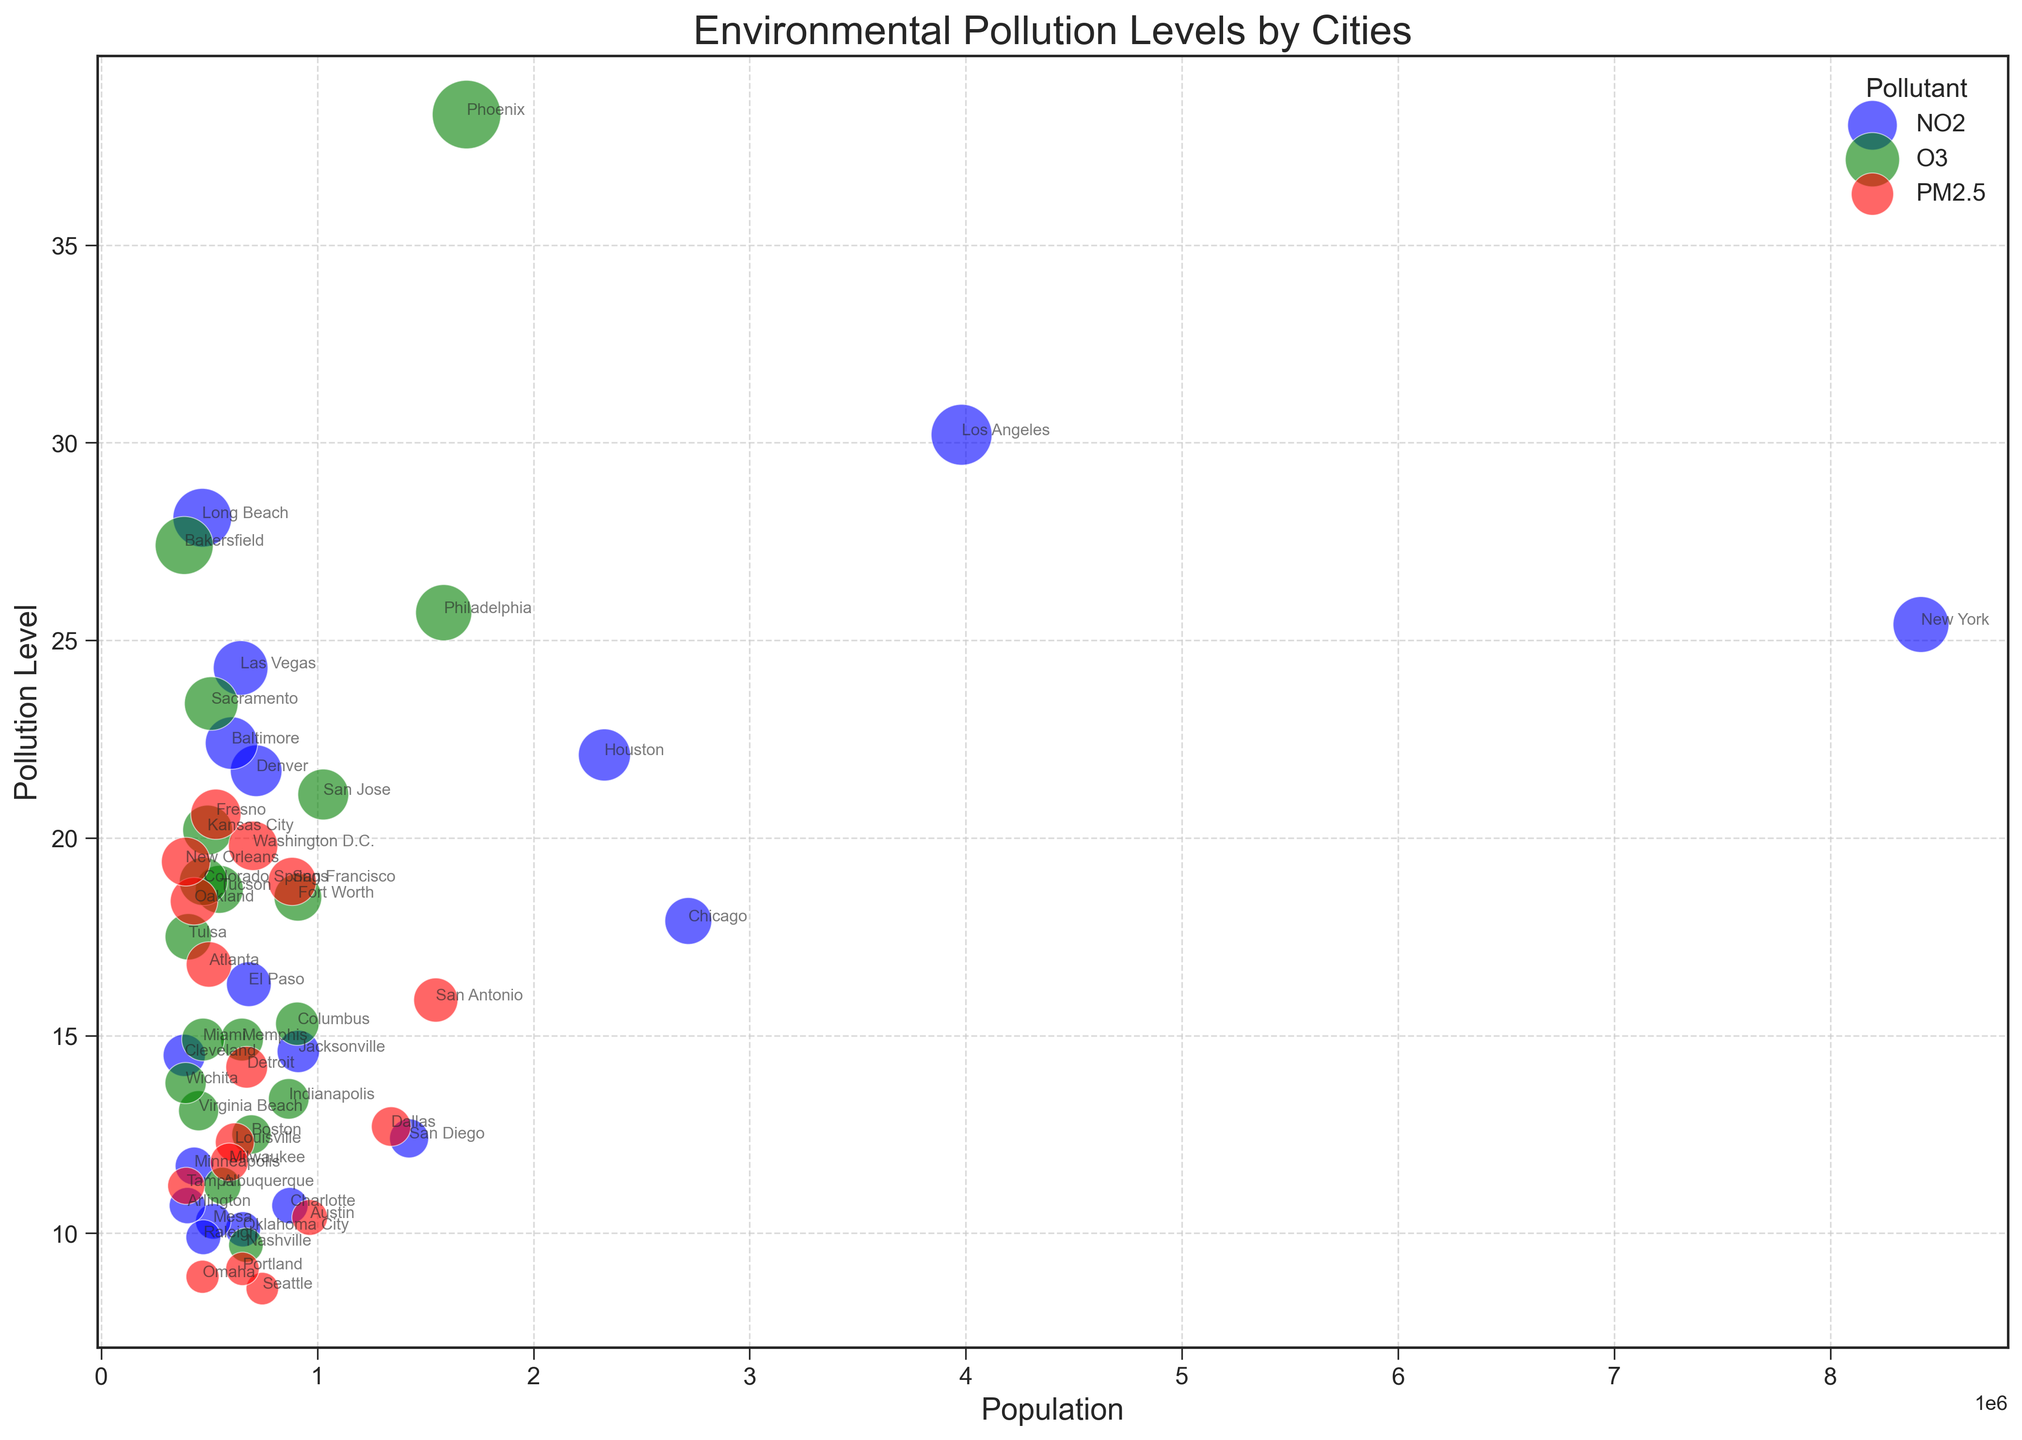Which city has the highest NO2 pollution level? The bubbles colored blue represent NO2 pollution levels. The city with the largest bubble among the blue bubbles indicates the highest NO2 pollution level.
Answer: Los Angeles What is the difference in PM2.5 levels between Seattle and Washington D.C.? Identify the red bubbles representing PM2.5 pollutants for both Seattle and Washington D.C., then subtract the pollution level of Seattle from that of Washington D.C.
Answer: 11.2 Which pollutant has the highest individual level observed in this chart? Check the largest bubbles among the grouped colors (blue for NO2, green for O3, and red for PM2.5) to find the highest individual level.
Answer: O3 Which city with a population under 500,000 has the highest pollution level? Look for bubbles below the 500,000 population mark on the x-axis, and identify the one with the highest position on the y-axis.
Answer: Bakersfield What is the average NO2 level for cities with populations over 2,000,000? Extract the NO2 levels for cities with populations over 2,000,000, sum these levels, and divide by the number of these cities: (New York, Los Angeles, Chicago, Houston).
Answer: 23.9 Which city has a higher O3 pollution level, Phoenix or San Francisco? Compare the green bubbles representing O3 levels for Phoenix and San Francisco, and identify the city with the higher position on the y-axis.
Answer: Phoenix If you combine the PM2.5 levels of Dallas, Detroit, and Atlanta, what is the total? Add the PM2.5 pollution levels for Dallas, Detroit, and Atlanta: 12.7 + 14.2 + 16.8.
Answer: 43.7 Which city stands out as an outlier for NO2 pollution given its high level but relatively low population? Look for a blue bubble that has a notable height on the y-axis signifying a high NO2 level but is positioned towards the lower end of the x-axis indicating a lower population.
Answer: Long Beach What is the median O3 pollution level among all cities that monitor this pollutant? List the O3 levels in ascending order and find the middle value. Levels are: 9.7, 11.2, 12.5, 13.1, 13.4, 14.9, 15.3, 17.5, 18.5, 18.7, 20.2, 21.1, 23.4, 25.7, 38.3. The median is the middle value in this ordered list.
Answer: 15.3 Between New York and Los Angeles, which city has a larger bubble size for NO2, and why does this make sense given their NO2 levels? Bubble size is proportional to the pollution level, check which city has a larger blue bubble and confirm by comparing their NO2 levels.
Answer: Los Angeles, because its NO2 level is 30.2 which is higher than New York's 25.4 